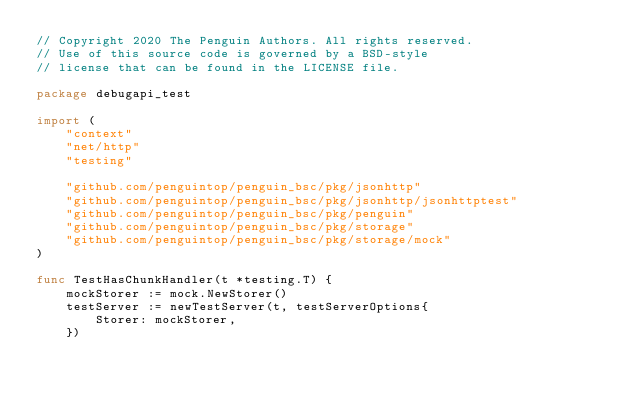<code> <loc_0><loc_0><loc_500><loc_500><_Go_>// Copyright 2020 The Penguin Authors. All rights reserved.
// Use of this source code is governed by a BSD-style
// license that can be found in the LICENSE file.

package debugapi_test

import (
	"context"
	"net/http"
	"testing"

	"github.com/penguintop/penguin_bsc/pkg/jsonhttp"
	"github.com/penguintop/penguin_bsc/pkg/jsonhttp/jsonhttptest"
	"github.com/penguintop/penguin_bsc/pkg/penguin"
	"github.com/penguintop/penguin_bsc/pkg/storage"
	"github.com/penguintop/penguin_bsc/pkg/storage/mock"
)

func TestHasChunkHandler(t *testing.T) {
	mockStorer := mock.NewStorer()
	testServer := newTestServer(t, testServerOptions{
		Storer: mockStorer,
	})
</code> 